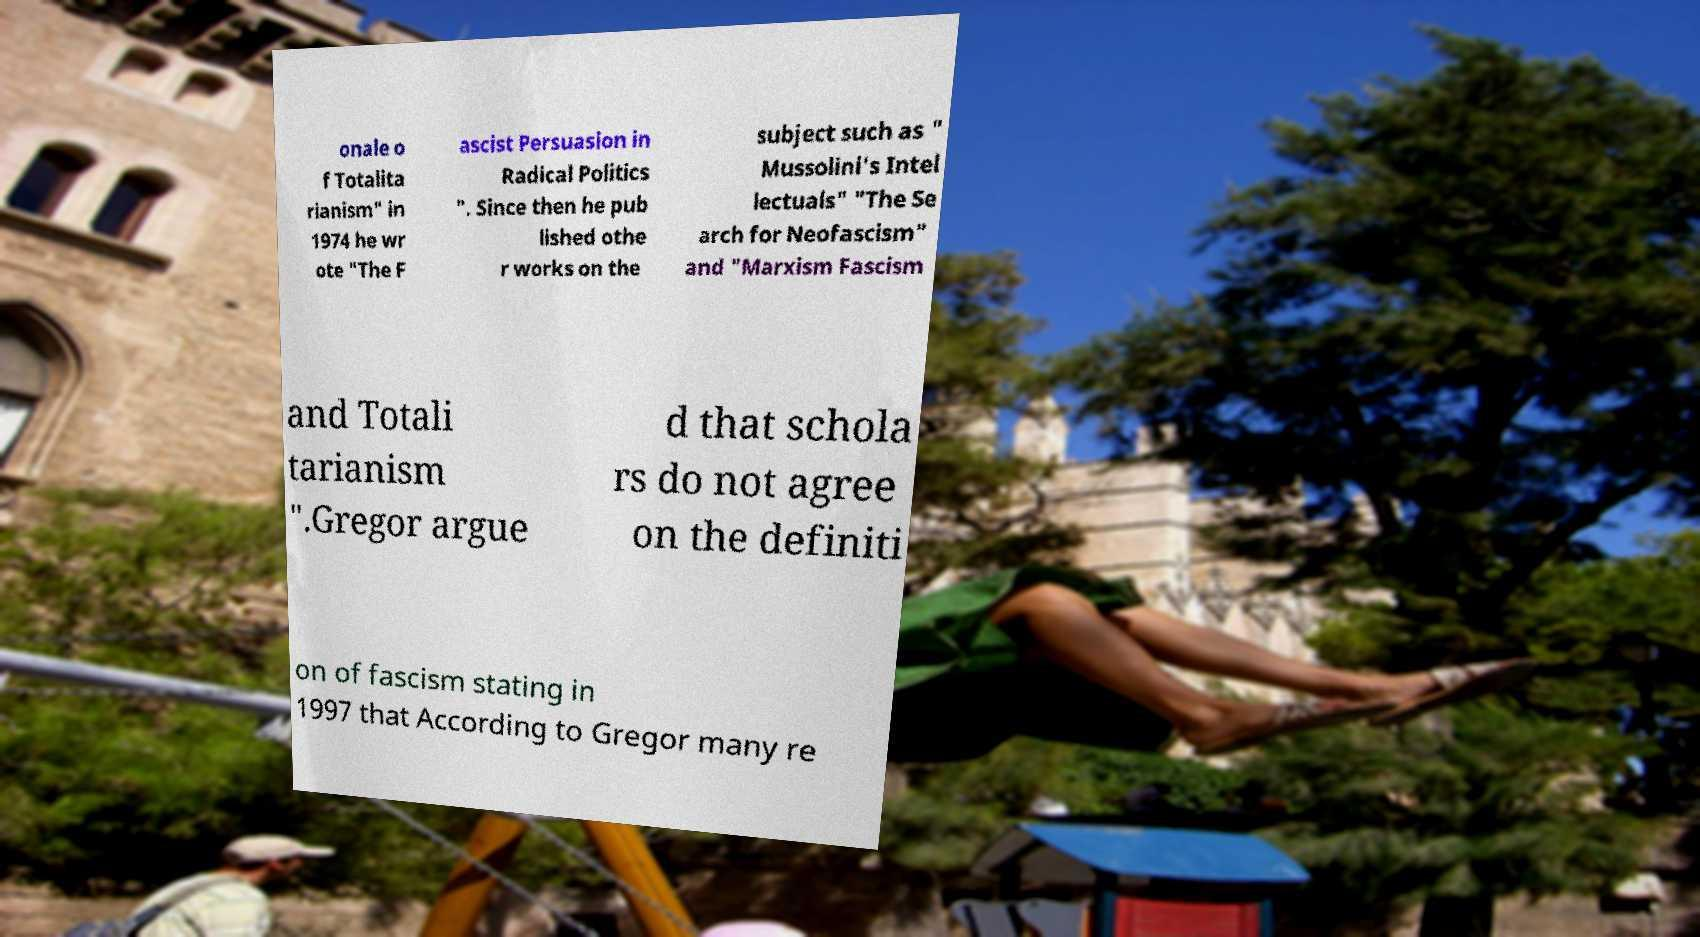Can you read and provide the text displayed in the image?This photo seems to have some interesting text. Can you extract and type it out for me? onale o f Totalita rianism" in 1974 he wr ote "The F ascist Persuasion in Radical Politics ". Since then he pub lished othe r works on the subject such as " Mussolini's Intel lectuals" "The Se arch for Neofascism" and "Marxism Fascism and Totali tarianism ".Gregor argue d that schola rs do not agree on the definiti on of fascism stating in 1997 that According to Gregor many re 